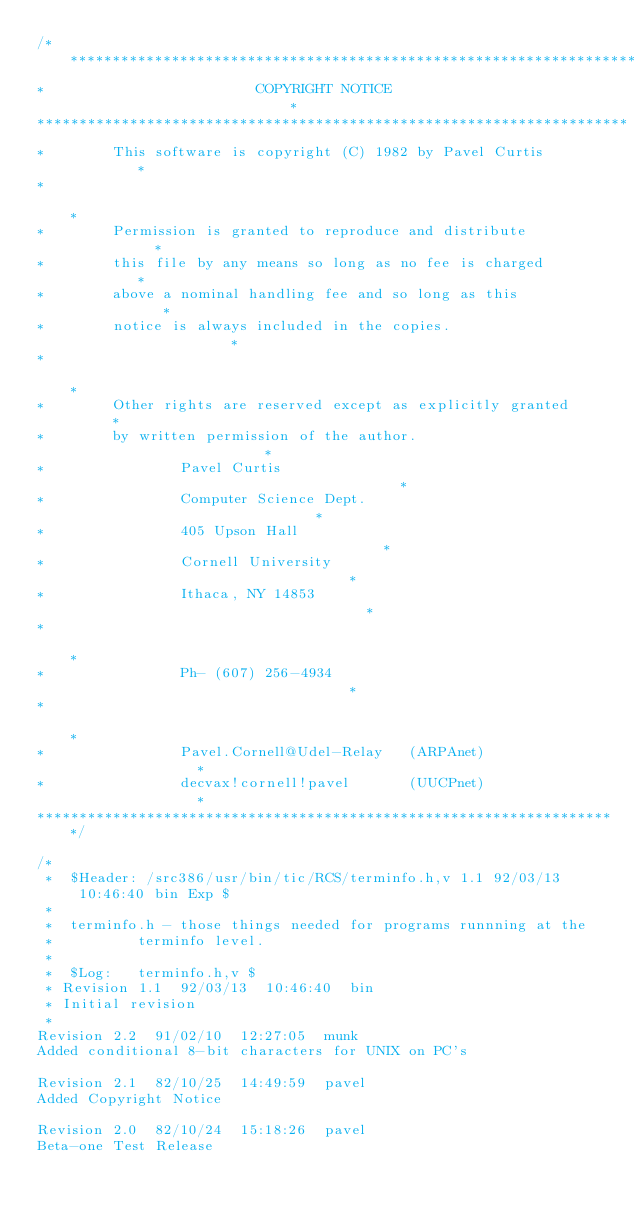Convert code to text. <code><loc_0><loc_0><loc_500><loc_500><_C_>/*********************************************************************
*                         COPYRIGHT NOTICE                           *
**********************************************************************
*        This software is copyright (C) 1982 by Pavel Curtis         *
*                                                                    *
*        Permission is granted to reproduce and distribute           *
*        this file by any means so long as no fee is charged         *
*        above a nominal handling fee and so long as this            *
*        notice is always included in the copies.                    *
*                                                                    *
*        Other rights are reserved except as explicitly granted      *
*        by written permission of the author.                        *
*                Pavel Curtis                                        *
*                Computer Science Dept.                              *
*                405 Upson Hall                                      *
*                Cornell University                                  *
*                Ithaca, NY 14853                                    *
*                                                                    *
*                Ph- (607) 256-4934                                  *
*                                                                    *
*                Pavel.Cornell@Udel-Relay   (ARPAnet)                *
*                decvax!cornell!pavel       (UUCPnet)                *
*********************************************************************/

/*
 *  $Header: /src386/usr/bin/tic/RCS/terminfo.h,v 1.1 92/03/13 10:46:40 bin Exp $
 *
 *	terminfo.h - those things needed for programs runnning at the
 *			terminfo level.
 *
 *  $Log:	terminfo.h,v $
 * Revision 1.1  92/03/13  10:46:40  bin
 * Initial revision
 * 
Revision 2.2  91/02/10  12:27:05  munk
Added conditional 8-bit characters for UNIX on PC's

Revision 2.1  82/10/25  14:49:59  pavel
Added Copyright Notice

Revision 2.0  82/10/24  15:18:26  pavel
Beta-one Test Release
</code> 